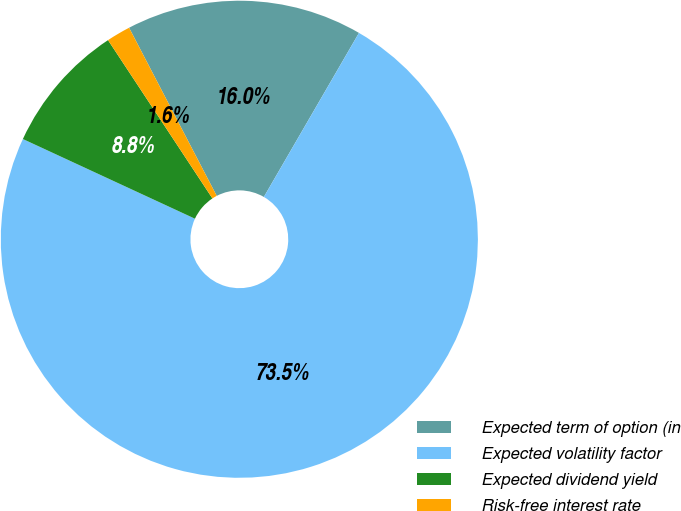Convert chart. <chart><loc_0><loc_0><loc_500><loc_500><pie_chart><fcel>Expected term of option (in<fcel>Expected volatility factor<fcel>Expected dividend yield<fcel>Risk-free interest rate<nl><fcel>16.01%<fcel>73.54%<fcel>8.82%<fcel>1.63%<nl></chart> 